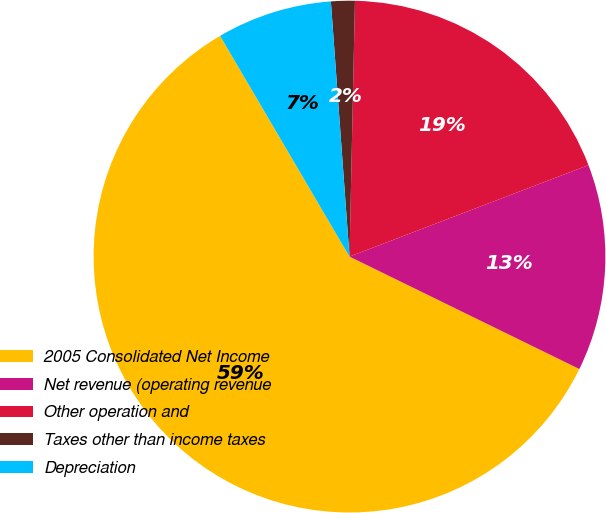Convert chart. <chart><loc_0><loc_0><loc_500><loc_500><pie_chart><fcel>2005 Consolidated Net Income<fcel>Net revenue (operating revenue<fcel>Other operation and<fcel>Taxes other than income taxes<fcel>Depreciation<nl><fcel>59.32%<fcel>13.06%<fcel>18.84%<fcel>1.5%<fcel>7.28%<nl></chart> 